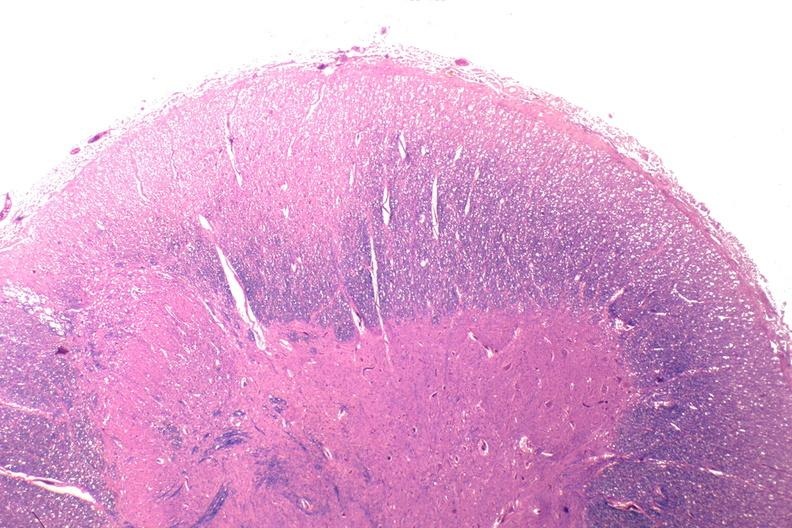why does this image show spinal cord injury?
Answer the question using a single word or phrase. Due to vertebral column trauma 